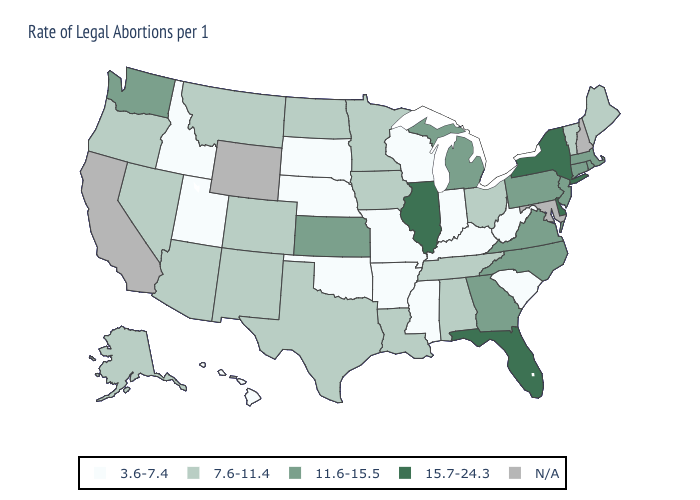How many symbols are there in the legend?
Keep it brief. 5. What is the value of New Mexico?
Answer briefly. 7.6-11.4. How many symbols are there in the legend?
Concise answer only. 5. What is the highest value in the MidWest ?
Keep it brief. 15.7-24.3. Name the states that have a value in the range N/A?
Answer briefly. California, Maryland, New Hampshire, Wyoming. What is the value of New York?
Write a very short answer. 15.7-24.3. Among the states that border Kentucky , which have the highest value?
Concise answer only. Illinois. Name the states that have a value in the range N/A?
Short answer required. California, Maryland, New Hampshire, Wyoming. What is the lowest value in states that border Missouri?
Keep it brief. 3.6-7.4. What is the value of Texas?
Give a very brief answer. 7.6-11.4. Among the states that border Georgia , which have the highest value?
Quick response, please. Florida. Among the states that border Kentucky , does Illinois have the highest value?
Give a very brief answer. Yes. Which states have the lowest value in the USA?
Keep it brief. Arkansas, Hawaii, Idaho, Indiana, Kentucky, Mississippi, Missouri, Nebraska, Oklahoma, South Carolina, South Dakota, Utah, West Virginia, Wisconsin. What is the highest value in states that border Virginia?
Be succinct. 11.6-15.5. 